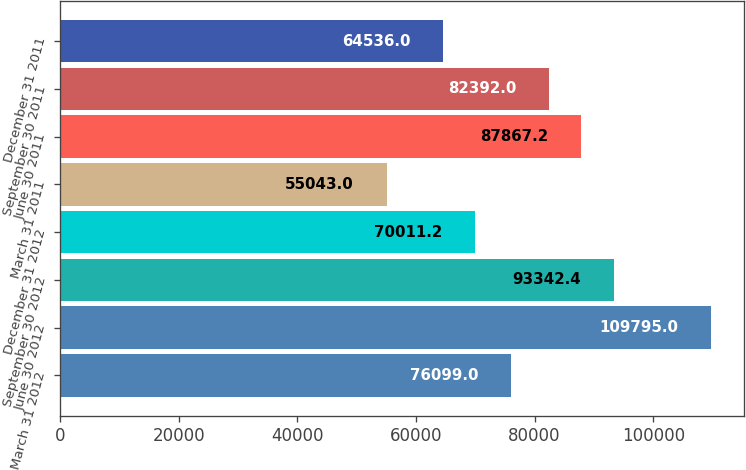<chart> <loc_0><loc_0><loc_500><loc_500><bar_chart><fcel>March 31 2012<fcel>June 30 2012<fcel>September 30 2012<fcel>December 31 2012<fcel>March 31 2011<fcel>June 30 2011<fcel>September 30 2011<fcel>December 31 2011<nl><fcel>76099<fcel>109795<fcel>93342.4<fcel>70011.2<fcel>55043<fcel>87867.2<fcel>82392<fcel>64536<nl></chart> 